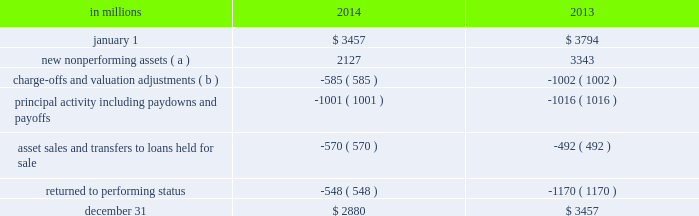Table 32 : change in nonperforming assets .
( a ) new nonperforming assets in the 2013 period include $ 560 million of loans added in the first quarter of 2013 due to the alignment with interagency supervisory guidance on practices for loans and lines of credit related to consumer lending .
( b ) charge-offs and valuation adjustments in the 2013 period include $ 134 million of charge-offs due to the alignment with interagency supervisory guidance discussed in footnote ( a ) above .
The table above presents nonperforming asset activity during 2014 and 2013 , respectively .
Nonperforming assets decreased $ 577 million from $ 3.5 billion at december 31 , 2013 to $ 2.9 billion at december 31 , 2014 , as a result of improvements in both consumer and commercial lending .
Consumer lending nonperforming loans decreased $ 224 million , commercial real estate nonperforming loans declined $ 184 million and commercial nonperforming loans decreased $ 167 million .
As of december 31 , 2014 , approximately 90% ( 90 % ) of total nonperforming loans were secured by collateral which lessens reserve requirements and is expected to reduce credit losses in the event of default .
As of december 31 , 2014 , commercial lending nonperforming loans were carried at approximately 65% ( 65 % ) of their unpaid principal balance , due to charge-offs recorded to date , before consideration of the alll .
See note 3 asset quality in the notes to consolidated financial statements in item 8 of this report for additional information on these loans .
Purchased impaired loans are considered performing , even if contractually past due ( or if we do not expect to receive payment in full based on the original contractual terms ) , as we accrete interest income over the expected life of the loans .
The accretable yield represents the excess of the expected cash flows on the loans at the measurement date over the carrying value .
Generally decreases , other than interest rate decreases for variable rate notes , in the net present value of expected cash flows of individual commercial or pooled purchased impaired loans would result in an impairment charge to the provision for credit losses in the period in which the change is deemed probable .
Generally increases in the net present value of expected cash flows of purchased impaired loans would first result in a recovery of previously recorded allowance for loan losses , to the extent applicable , and then an increase to accretable yield for the remaining life of the purchased impaired loans .
Total nonperforming loans and assets in the tables above are significantly lower than they would have been due to this accounting treatment for purchased impaired loans .
This treatment also results in a lower ratio of nonperforming loans to total loans and a higher ratio of alll to nonperforming loans .
See note 4 purchased loans in the notes to consolidated financial statements in item 8 of this report for additional information on these loans .
Loan delinquencies we regularly monitor the level of loan delinquencies and believe these levels may be a key indicator of loan portfolio asset quality .
Measurement of delinquency status is based on the contractual terms of each loan .
Loans that are 30 days or more past due in terms of payment are considered delinquent .
Loan delinquencies exclude loans held for sale and purchased impaired loans , but include government insured or guaranteed loans and loans accounted for under the fair value option .
Total early stage loan delinquencies ( accruing loans past due 30 to 89 days ) decreased from $ 1.0 billion at december 31 , 2013 to $ 0.8 billion at december 31 , 2014 .
The reduction in both consumer and commercial lending early stage delinquencies resulted from improved credit quality .
See note 1 accounting policies in the notes to consolidated financial statements of this report for additional information regarding our nonperforming loan and nonaccrual policies .
Accruing loans past due 90 days or more are referred to as late stage delinquencies .
These loans are not included in nonperforming loans and continue to accrue interest because they are well secured by collateral , and/or are in the process of collection , are managed in homogenous portfolios with specified charge-off timeframes adhering to regulatory guidelines , or are certain government insured or guaranteed loans .
These loans decreased $ .4 billion , or 26% ( 26 % ) , from $ 1.5 billion at december 31 , 2013 to $ 1.1 billion at december 31 , 2014 , mainly due to a decline in government insured residential real estate loans of $ .3 billion , the majority of which we took possession of and conveyed the real estate , or are in the process of conveyance and claim resolution .
The following tables display the delinquency status of our loans at december 31 , 2014 and december 31 , 2013 .
Additional information regarding accruing loans past due is included in note 3 asset quality in the notes to consolidated financial statements of this report .
74 the pnc financial services group , inc .
2013 form 10-k .
By how much , in billions , did early stage loans decrease between dec 31 2013 and dec 31 2014? 
Computations: (1 - 0.8)
Answer: 0.2. 